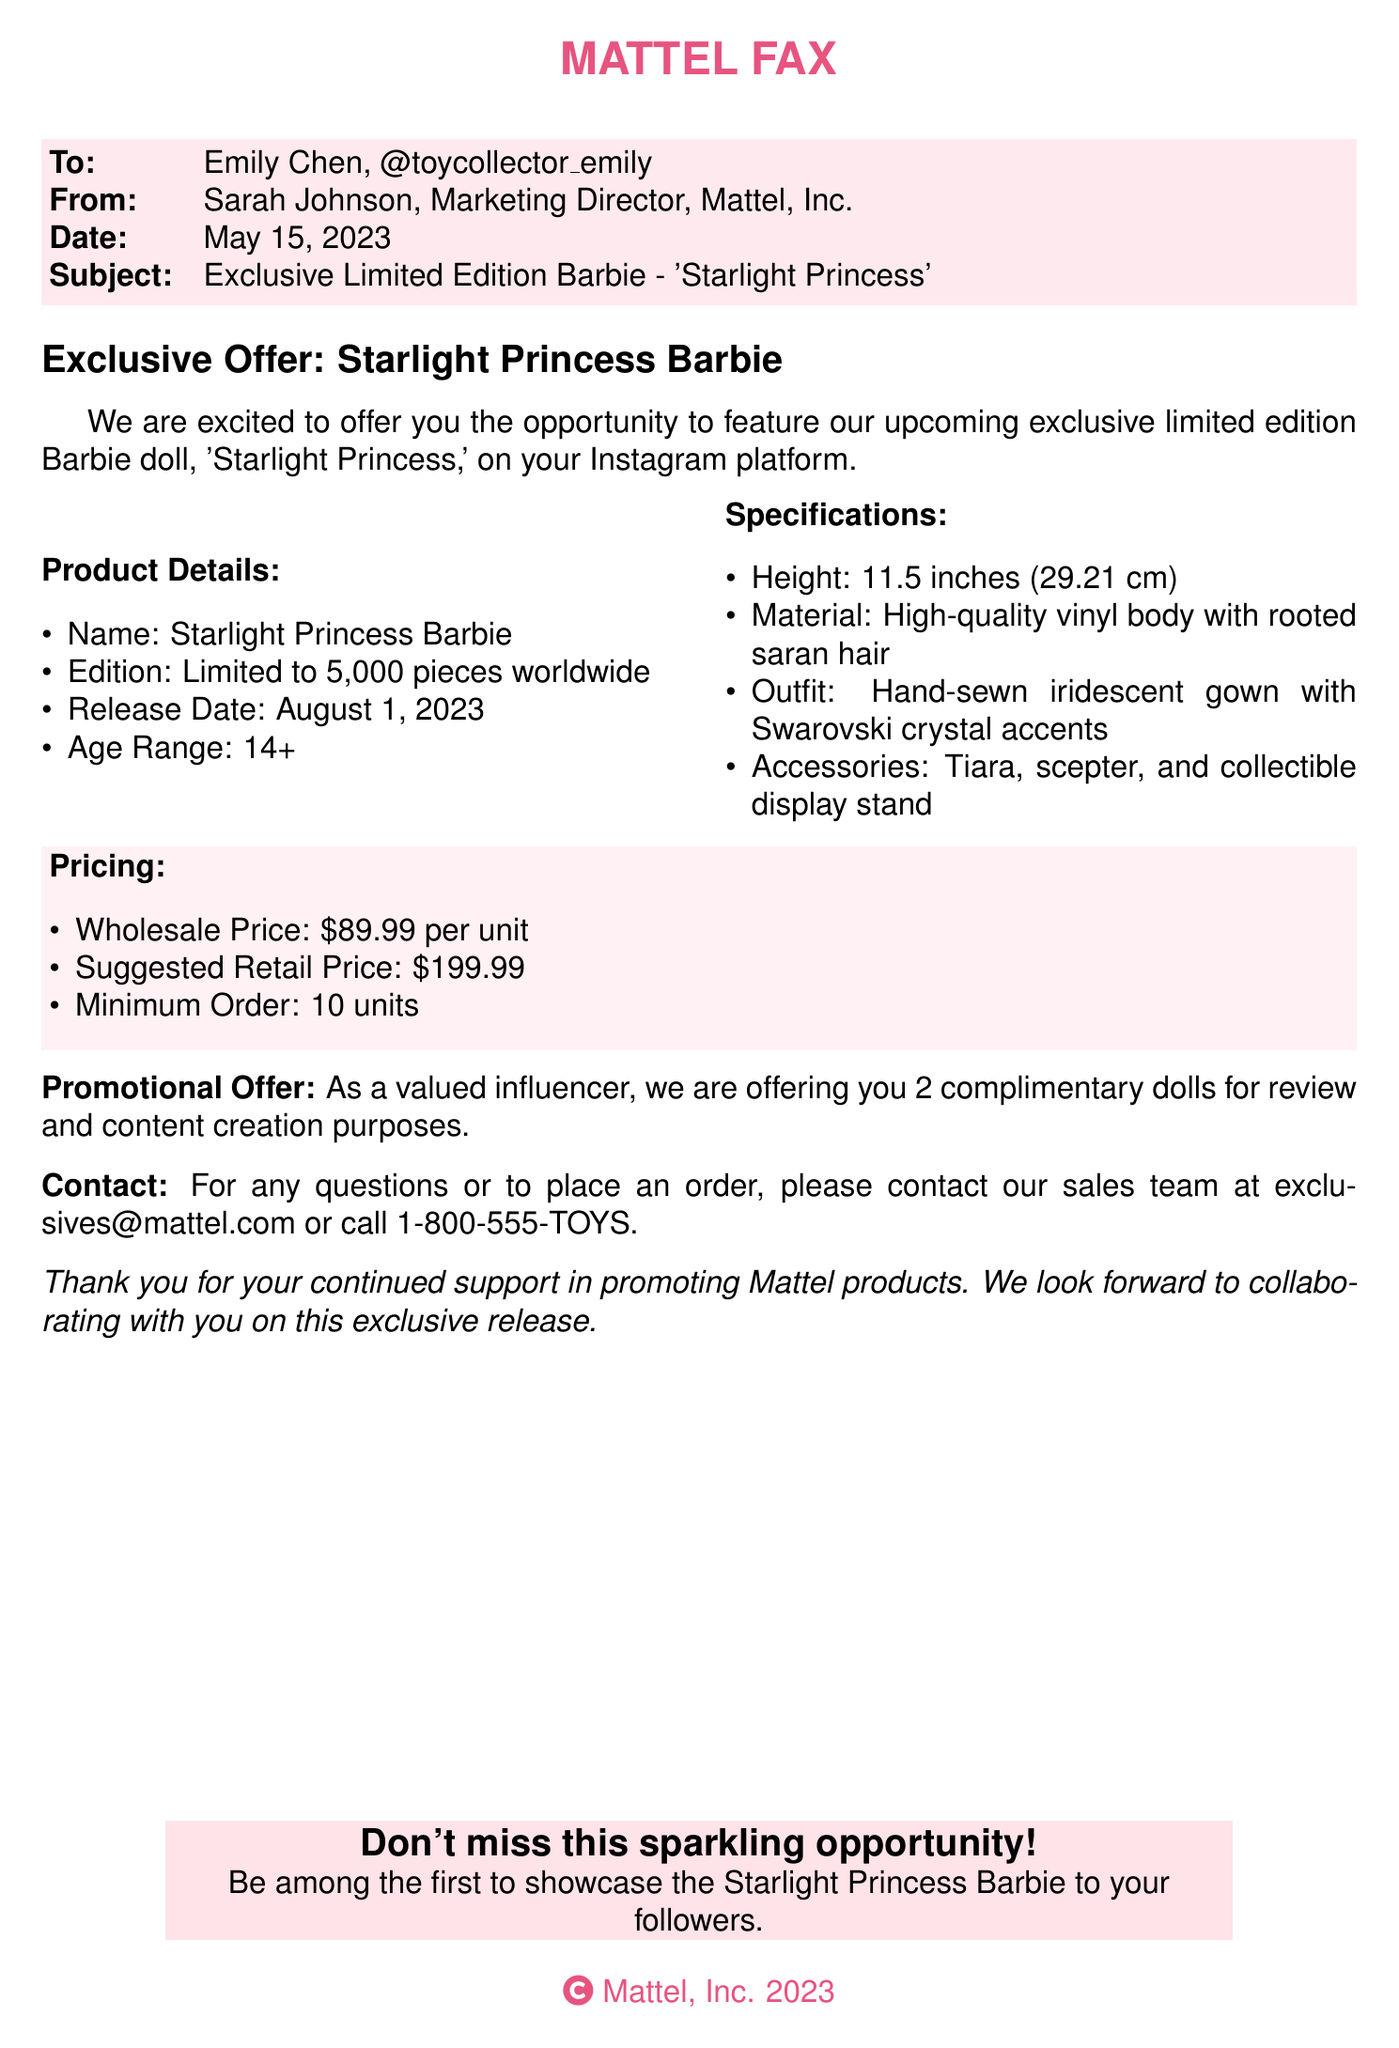What is the name of the collectible? The name of the collectible is mentioned as 'Starlight Princess Barbie.'
Answer: Starlight Princess Barbie How many pieces are being released? The document states that the edition is limited to 5,000 pieces worldwide.
Answer: 5,000 pieces What is the suggested retail price? The suggested retail price for the doll is explicitly mentioned in the pricing section.
Answer: $199.99 What age range is this collectible designed for? The age range provided in the product details indicates that it is for ages 14 and up.
Answer: 14+ What is included with the doll as accessories? A list of accessories includes a tiara, scepter, and collectible display stand.
Answer: Tiara, scepter, and collectible display stand What is the minimum order requirement? The minimum order requirement is specified in the pricing section of the document.
Answer: 10 units Who is the contact person for orders? The fax indicates that inquiries should be directed to the sales team via a provided email address.
Answer: Sales team When is the release date for the collectible? The release date for the Starlight Princess Barbie is clearly stated as August 1, 2023.
Answer: August 1, 2023 What promotional offer is extended to the influencer? The document mentions that the influencer is offered 2 complimentary dolls for review purposes.
Answer: 2 complimentary dolls What material is the doll made of? The specifications highlight that the doll is made of high-quality vinyl body with rooted saran hair.
Answer: High-quality vinyl body with rooted saran hair 